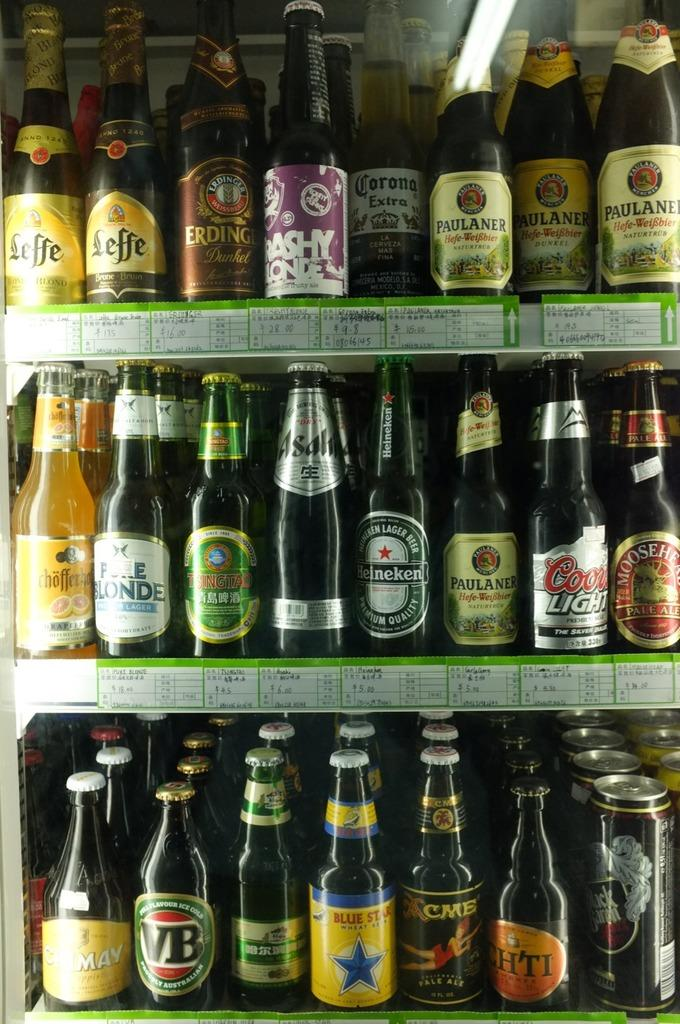<image>
Offer a succinct explanation of the picture presented. many bottles with one that says VB on it 